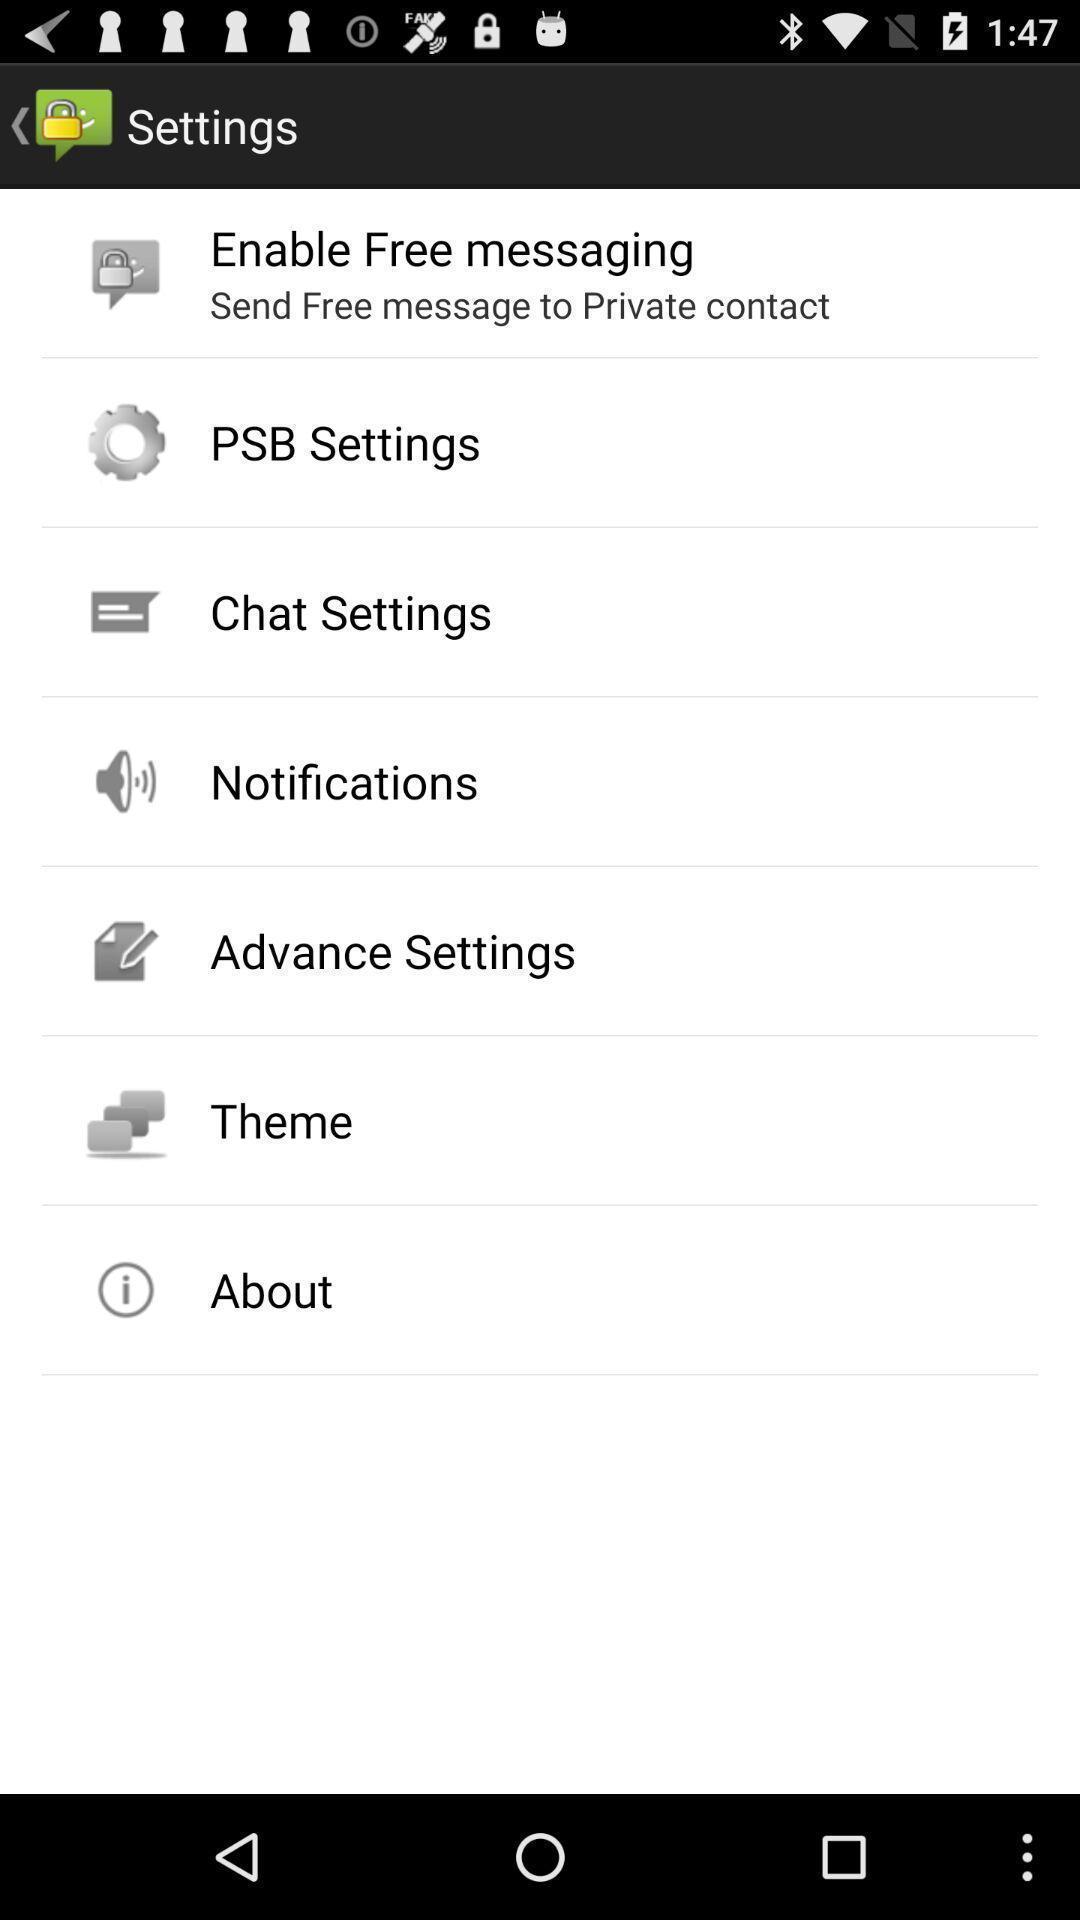What details can you identify in this image? Settings page of a messaging app. 